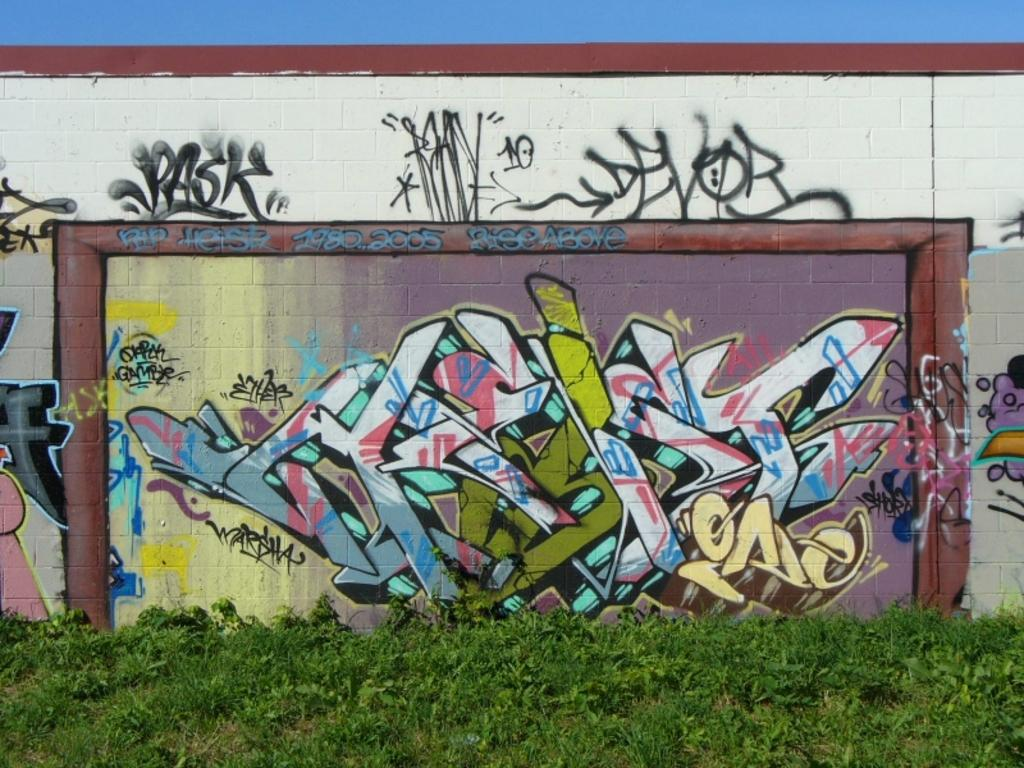What type of living organisms can be seen in the image? Plants can be seen in the image. What is located behind the plants in the image? There is a wall in the image. What is featured on the wall in the image? The wall contains some art. What is visible at the top of the image? The sky is visible at the top of the image. What type of hospital can be seen in the image? There is no hospital present in the image; it features plants, a wall, and art on the wall. What kind of meeting is taking place in the image? There is no meeting taking place in the image; it is a still image of plants, a wall, and art on the wall. 